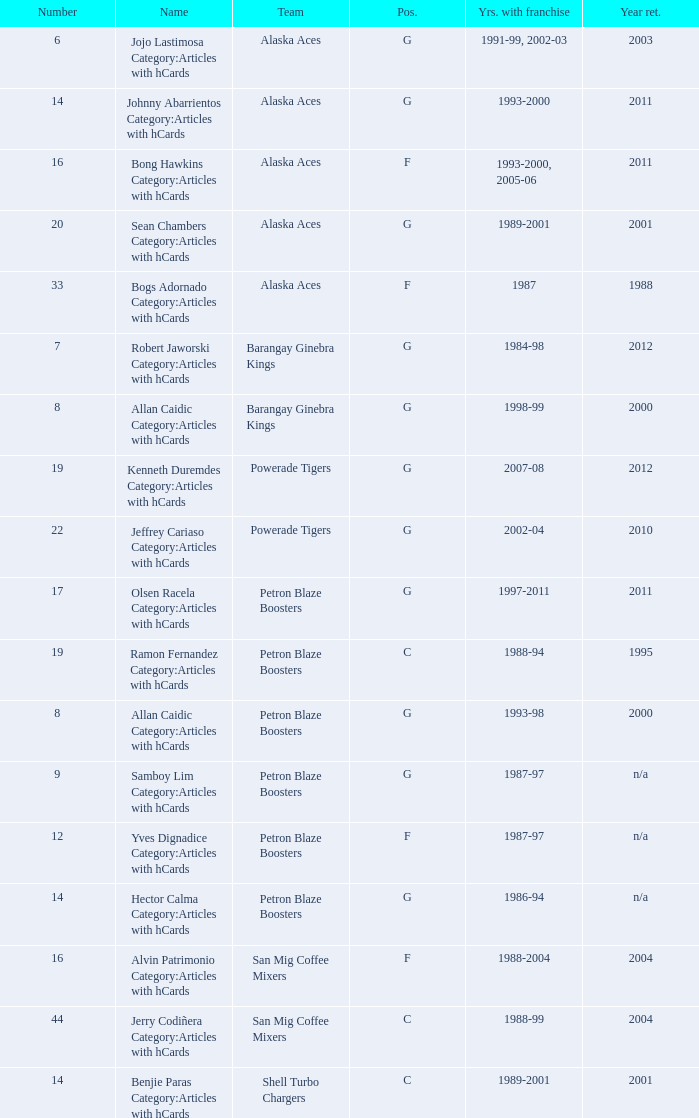Who was the player in Position G on the Petron Blaze Boosters and retired in 2000? Allan Caidic Category:Articles with hCards. 